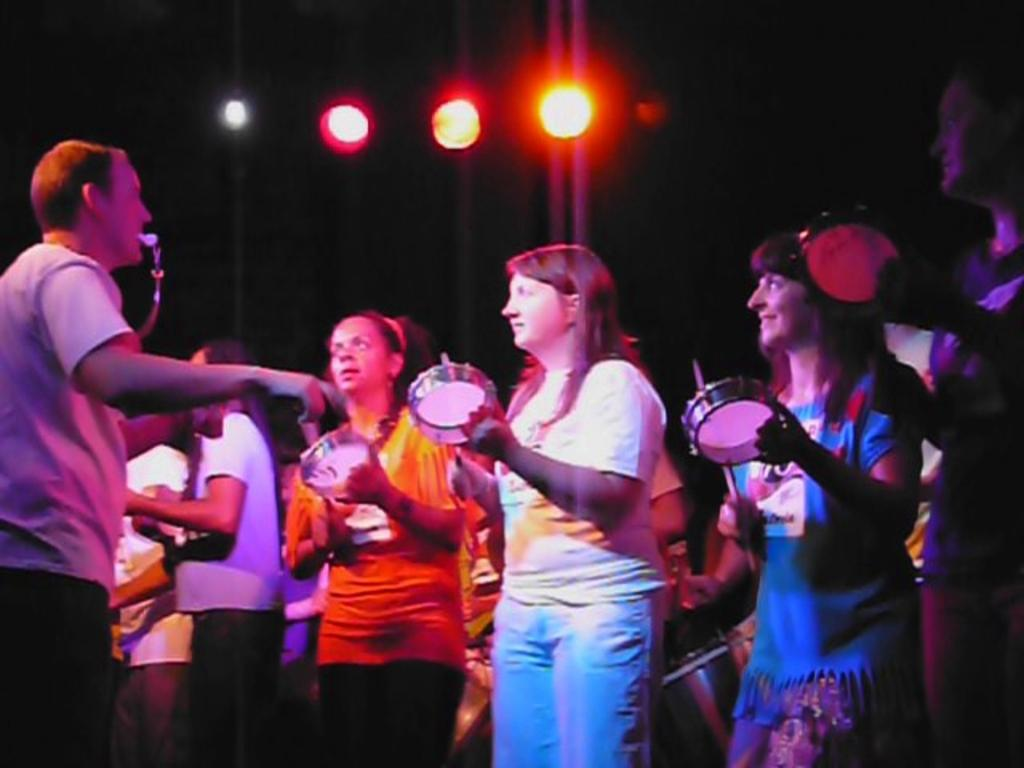How many people are in the image? There is a group of persons in the image. What are the persons in the image doing? The persons are standing and holding musical instruments in their hands. What can be seen in the background of the image? There are lights in the background of the image. What type of toothpaste is being used by the persons in the image? There is no toothpaste present in the image; the persons are holding musical instruments. What acoustics can be heard from the musical instruments in the image? The image does not provide any auditory information, so it is not possible to determine the acoustics of the musical instruments. 